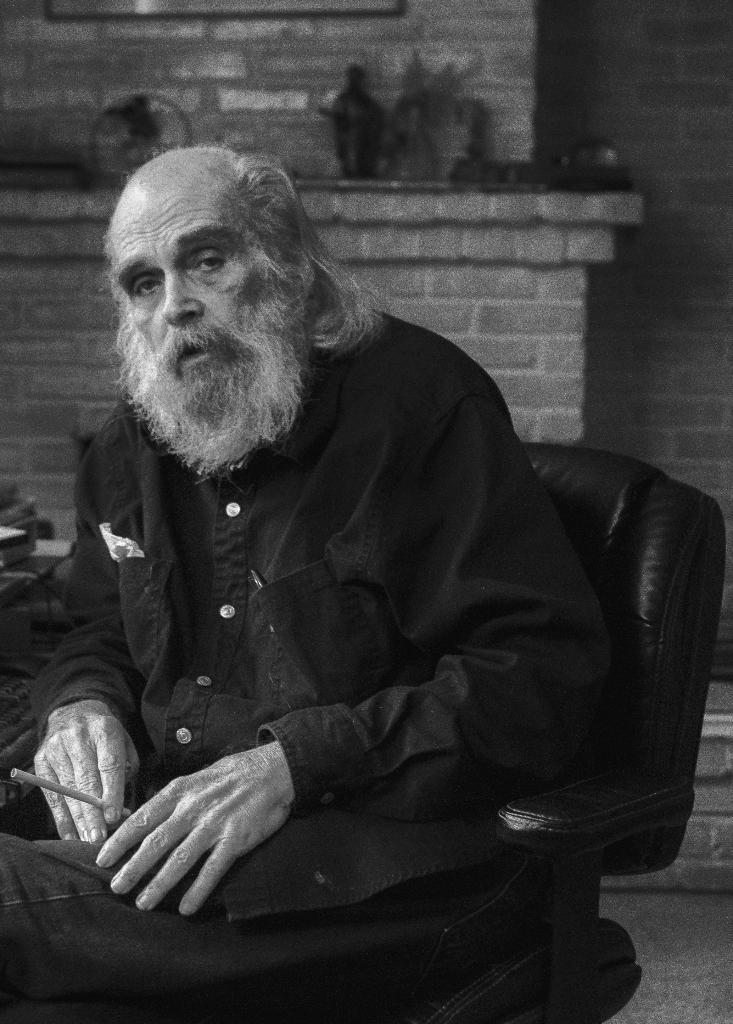What is present in the image that serves as a background or boundary? There is a wall in the image. What is the man in the image doing? The man is sitting on a chair in the image. What type of blade is being used by the man in the image? There is no blade present in the image; the man is simply sitting on a chair. How many family members can be seen in the image? There is no family member present in the image besides the man sitting on the chair. 